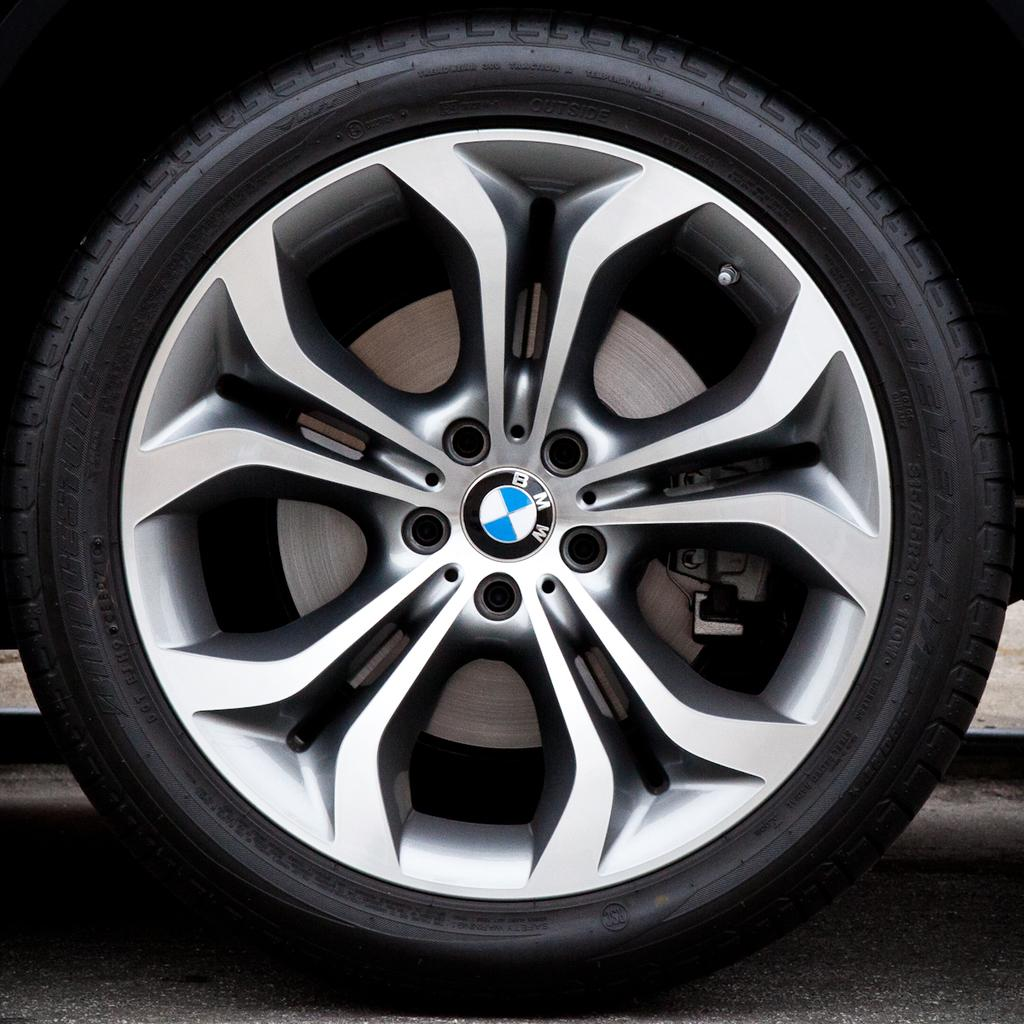What can be seen in the picture? There is a tyre in the picture. What additional detail can be observed on the tyre? There is a BMW logo on the rim of the tyre. Is there a veil covering the tyre in the image? No, there is no veil present in the image. What is the value of the tyre in the image? The value of the tyre cannot be determined from the image alone. 